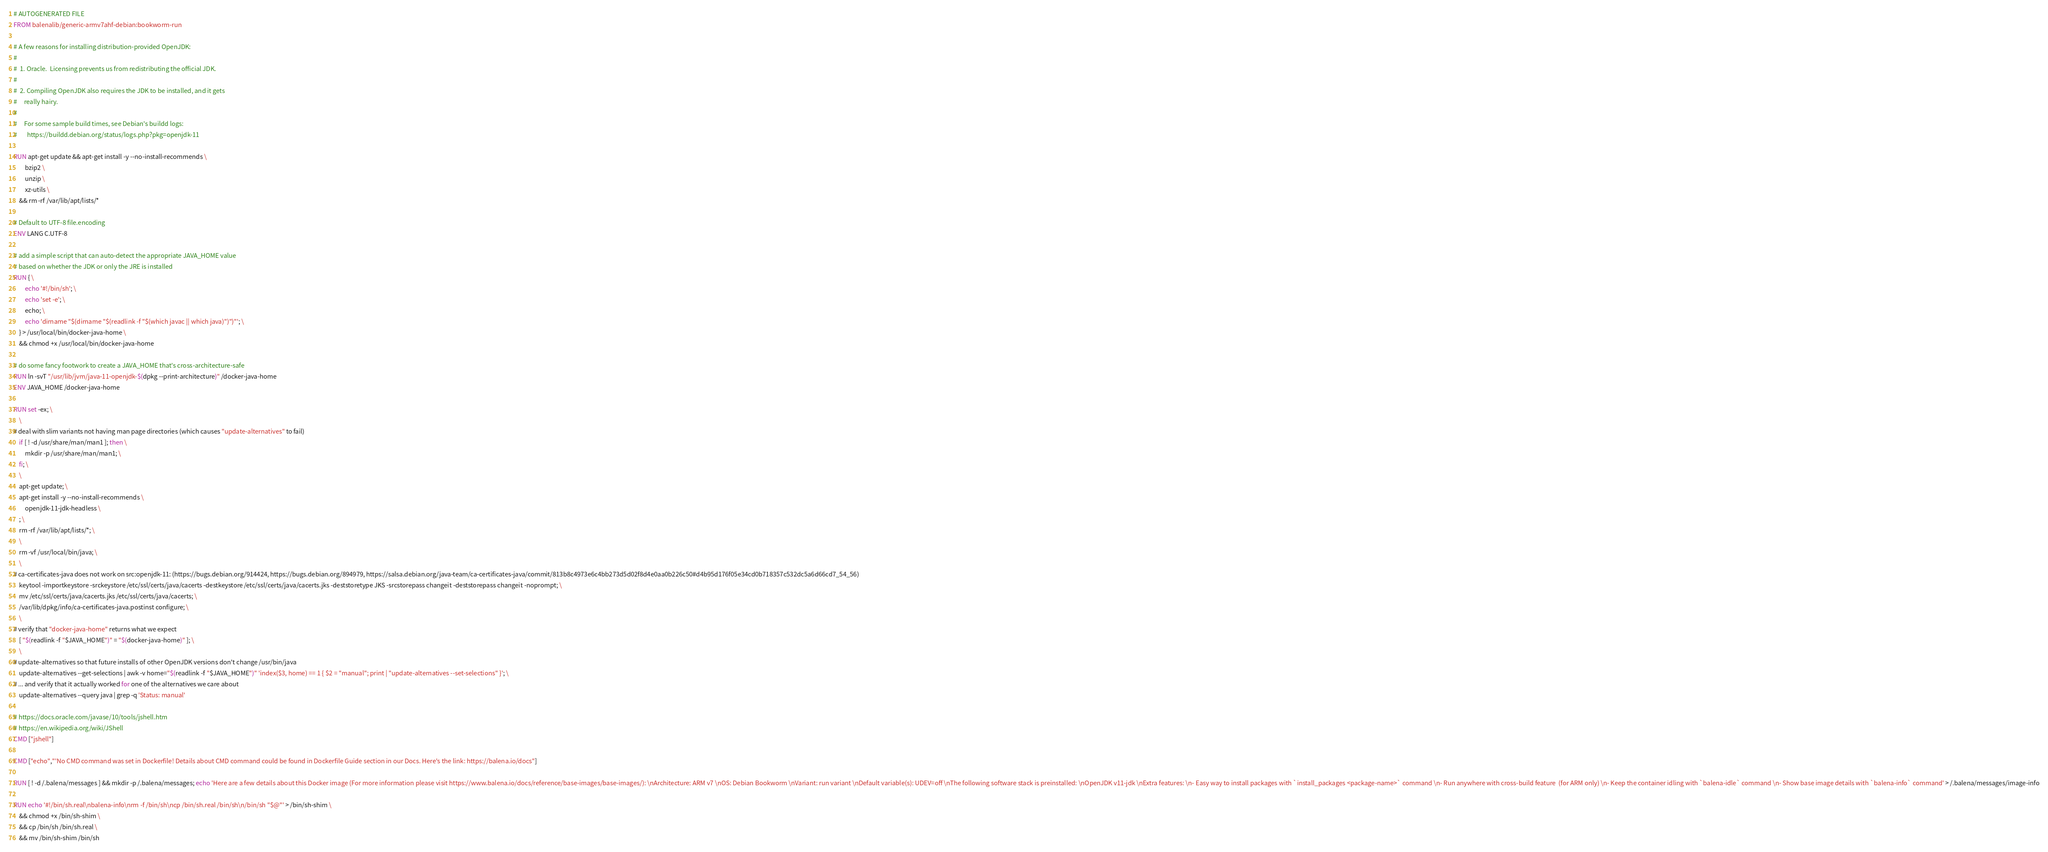Convert code to text. <code><loc_0><loc_0><loc_500><loc_500><_Dockerfile_># AUTOGENERATED FILE
FROM balenalib/generic-armv7ahf-debian:bookworm-run

# A few reasons for installing distribution-provided OpenJDK:
#
#  1. Oracle.  Licensing prevents us from redistributing the official JDK.
#
#  2. Compiling OpenJDK also requires the JDK to be installed, and it gets
#     really hairy.
#
#     For some sample build times, see Debian's buildd logs:
#       https://buildd.debian.org/status/logs.php?pkg=openjdk-11

RUN apt-get update && apt-get install -y --no-install-recommends \
		bzip2 \
		unzip \
		xz-utils \
	&& rm -rf /var/lib/apt/lists/*

# Default to UTF-8 file.encoding
ENV LANG C.UTF-8

# add a simple script that can auto-detect the appropriate JAVA_HOME value
# based on whether the JDK or only the JRE is installed
RUN { \
		echo '#!/bin/sh'; \
		echo 'set -e'; \
		echo; \
		echo 'dirname "$(dirname "$(readlink -f "$(which javac || which java)")")"'; \
	} > /usr/local/bin/docker-java-home \
	&& chmod +x /usr/local/bin/docker-java-home

# do some fancy footwork to create a JAVA_HOME that's cross-architecture-safe
RUN ln -svT "/usr/lib/jvm/java-11-openjdk-$(dpkg --print-architecture)" /docker-java-home
ENV JAVA_HOME /docker-java-home

RUN set -ex; \
	\
# deal with slim variants not having man page directories (which causes "update-alternatives" to fail)
	if [ ! -d /usr/share/man/man1 ]; then \
		mkdir -p /usr/share/man/man1; \
	fi; \
	\
	apt-get update; \
	apt-get install -y --no-install-recommends \
		openjdk-11-jdk-headless \
	; \
	rm -rf /var/lib/apt/lists/*; \
	\
	rm -vf /usr/local/bin/java; \
	\
# ca-certificates-java does not work on src:openjdk-11: (https://bugs.debian.org/914424, https://bugs.debian.org/894979, https://salsa.debian.org/java-team/ca-certificates-java/commit/813b8c4973e6c4bb273d5d02f8d4e0aa0b226c50#d4b95d176f05e34cd0b718357c532dc5a6d66cd7_54_56)
	keytool -importkeystore -srckeystore /etc/ssl/certs/java/cacerts -destkeystore /etc/ssl/certs/java/cacerts.jks -deststoretype JKS -srcstorepass changeit -deststorepass changeit -noprompt; \
	mv /etc/ssl/certs/java/cacerts.jks /etc/ssl/certs/java/cacerts; \
	/var/lib/dpkg/info/ca-certificates-java.postinst configure; \
	\
# verify that "docker-java-home" returns what we expect
	[ "$(readlink -f "$JAVA_HOME")" = "$(docker-java-home)" ]; \
	\
# update-alternatives so that future installs of other OpenJDK versions don't change /usr/bin/java
	update-alternatives --get-selections | awk -v home="$(readlink -f "$JAVA_HOME")" 'index($3, home) == 1 { $2 = "manual"; print | "update-alternatives --set-selections" }'; \
# ... and verify that it actually worked for one of the alternatives we care about
	update-alternatives --query java | grep -q 'Status: manual'

# https://docs.oracle.com/javase/10/tools/jshell.htm
# https://en.wikipedia.org/wiki/JShell
CMD ["jshell"]

CMD ["echo","'No CMD command was set in Dockerfile! Details about CMD command could be found in Dockerfile Guide section in our Docs. Here's the link: https://balena.io/docs"]

RUN [ ! -d /.balena/messages ] && mkdir -p /.balena/messages; echo 'Here are a few details about this Docker image (For more information please visit https://www.balena.io/docs/reference/base-images/base-images/): \nArchitecture: ARM v7 \nOS: Debian Bookworm \nVariant: run variant \nDefault variable(s): UDEV=off \nThe following software stack is preinstalled: \nOpenJDK v11-jdk \nExtra features: \n- Easy way to install packages with `install_packages <package-name>` command \n- Run anywhere with cross-build feature  (for ARM only) \n- Keep the container idling with `balena-idle` command \n- Show base image details with `balena-info` command' > /.balena/messages/image-info

RUN echo '#!/bin/sh.real\nbalena-info\nrm -f /bin/sh\ncp /bin/sh.real /bin/sh\n/bin/sh "$@"' > /bin/sh-shim \
	&& chmod +x /bin/sh-shim \
	&& cp /bin/sh /bin/sh.real \
	&& mv /bin/sh-shim /bin/sh</code> 